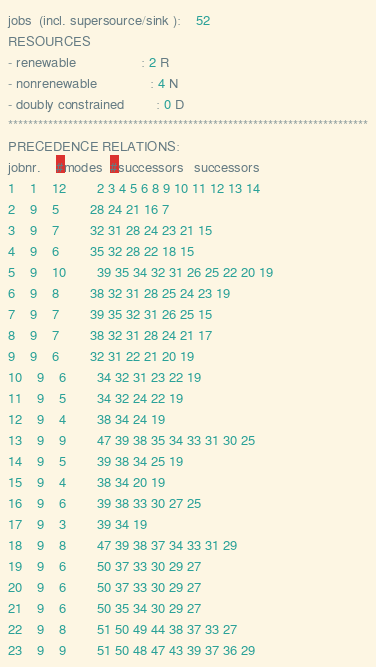Convert code to text. <code><loc_0><loc_0><loc_500><loc_500><_ObjectiveC_>jobs  (incl. supersource/sink ):	52
RESOURCES
- renewable                 : 2 R
- nonrenewable              : 4 N
- doubly constrained        : 0 D
************************************************************************
PRECEDENCE RELATIONS:
jobnr.    #modes  #successors   successors
1	1	12		2 3 4 5 6 8 9 10 11 12 13 14 
2	9	5		28 24 21 16 7 
3	9	7		32 31 28 24 23 21 15 
4	9	6		35 32 28 22 18 15 
5	9	10		39 35 34 32 31 26 25 22 20 19 
6	9	8		38 32 31 28 25 24 23 19 
7	9	7		39 35 32 31 26 25 15 
8	9	7		38 32 31 28 24 21 17 
9	9	6		32 31 22 21 20 19 
10	9	6		34 32 31 23 22 19 
11	9	5		34 32 24 22 19 
12	9	4		38 34 24 19 
13	9	9		47 39 38 35 34 33 31 30 25 
14	9	5		39 38 34 25 19 
15	9	4		38 34 20 19 
16	9	6		39 38 33 30 27 25 
17	9	3		39 34 19 
18	9	8		47 39 38 37 34 33 31 29 
19	9	6		50 37 33 30 29 27 
20	9	6		50 37 33 30 29 27 
21	9	6		50 35 34 30 29 27 
22	9	8		51 50 49 44 38 37 33 27 
23	9	9		51 50 48 47 43 39 37 36 29 </code> 